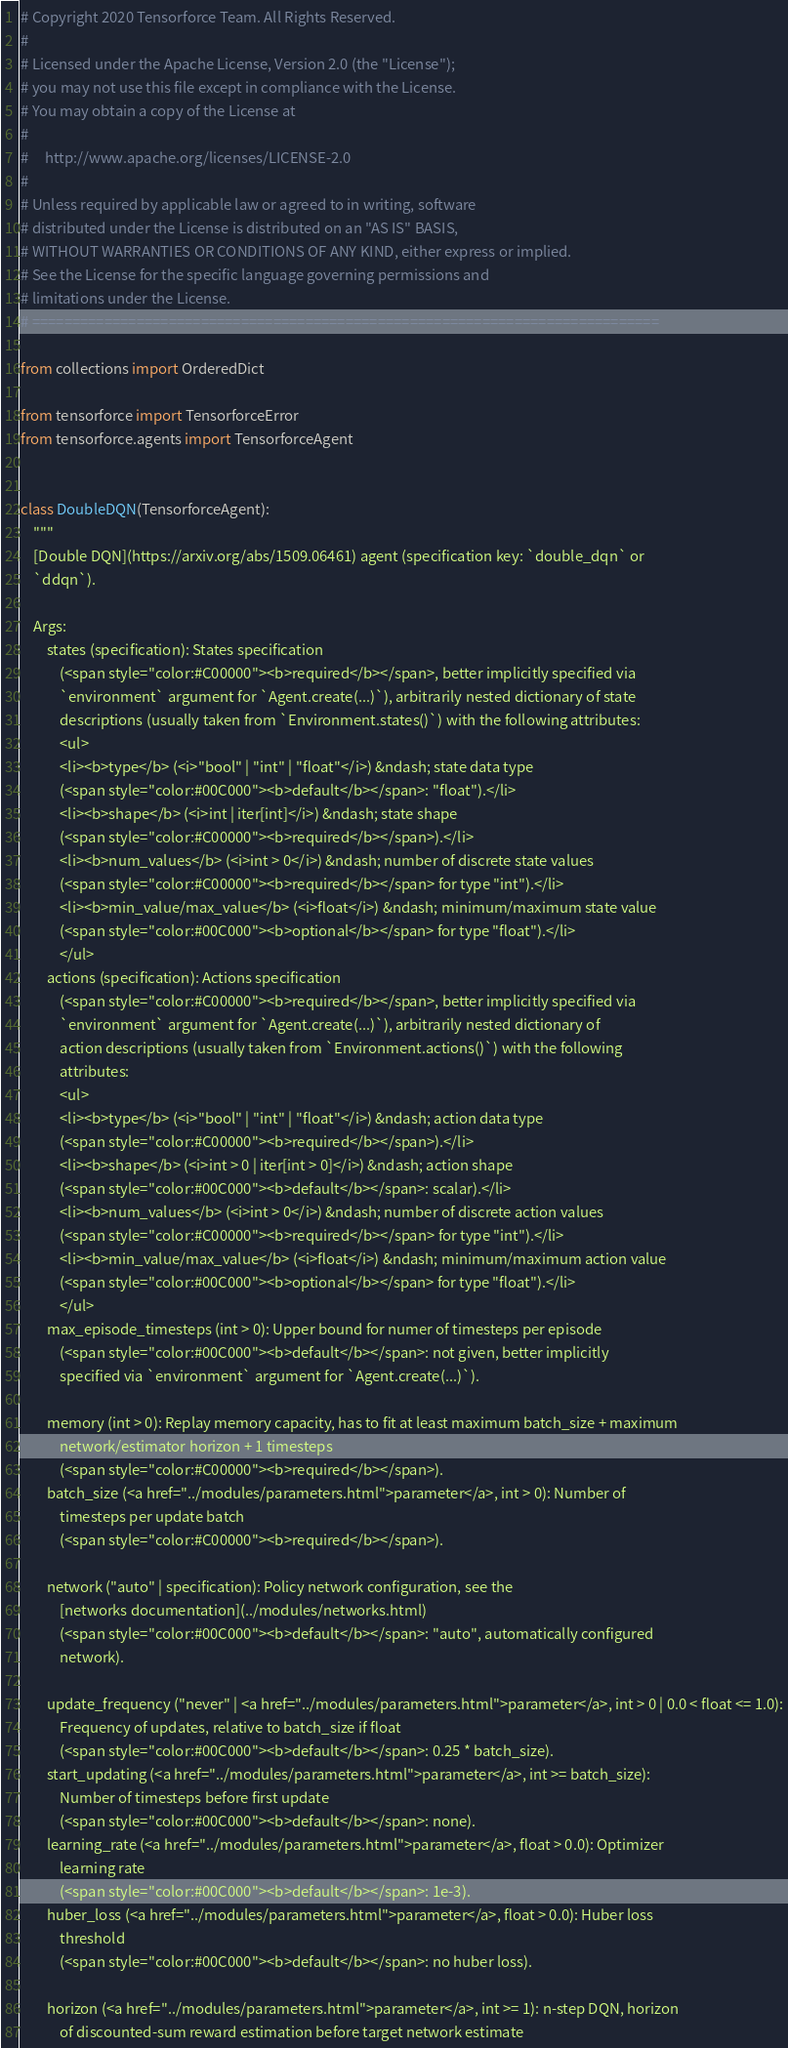<code> <loc_0><loc_0><loc_500><loc_500><_Python_># Copyright 2020 Tensorforce Team. All Rights Reserved.
#
# Licensed under the Apache License, Version 2.0 (the "License");
# you may not use this file except in compliance with the License.
# You may obtain a copy of the License at
#
#     http://www.apache.org/licenses/LICENSE-2.0
#
# Unless required by applicable law or agreed to in writing, software
# distributed under the License is distributed on an "AS IS" BASIS,
# WITHOUT WARRANTIES OR CONDITIONS OF ANY KIND, either express or implied.
# See the License for the specific language governing permissions and
# limitations under the License.
# ==============================================================================

from collections import OrderedDict

from tensorforce import TensorforceError
from tensorforce.agents import TensorforceAgent


class DoubleDQN(TensorforceAgent):
    """
    [Double DQN](https://arxiv.org/abs/1509.06461) agent (specification key: `double_dqn` or
    `ddqn`).

    Args:
        states (specification): States specification
            (<span style="color:#C00000"><b>required</b></span>, better implicitly specified via
            `environment` argument for `Agent.create(...)`), arbitrarily nested dictionary of state
            descriptions (usually taken from `Environment.states()`) with the following attributes:
            <ul>
            <li><b>type</b> (<i>"bool" | "int" | "float"</i>) &ndash; state data type
            (<span style="color:#00C000"><b>default</b></span>: "float").</li>
            <li><b>shape</b> (<i>int | iter[int]</i>) &ndash; state shape
            (<span style="color:#C00000"><b>required</b></span>).</li>
            <li><b>num_values</b> (<i>int > 0</i>) &ndash; number of discrete state values
            (<span style="color:#C00000"><b>required</b></span> for type "int").</li>
            <li><b>min_value/max_value</b> (<i>float</i>) &ndash; minimum/maximum state value
            (<span style="color:#00C000"><b>optional</b></span> for type "float").</li>
            </ul>
        actions (specification): Actions specification
            (<span style="color:#C00000"><b>required</b></span>, better implicitly specified via
            `environment` argument for `Agent.create(...)`), arbitrarily nested dictionary of
            action descriptions (usually taken from `Environment.actions()`) with the following
            attributes:
            <ul>
            <li><b>type</b> (<i>"bool" | "int" | "float"</i>) &ndash; action data type
            (<span style="color:#C00000"><b>required</b></span>).</li>
            <li><b>shape</b> (<i>int > 0 | iter[int > 0]</i>) &ndash; action shape
            (<span style="color:#00C000"><b>default</b></span>: scalar).</li>
            <li><b>num_values</b> (<i>int > 0</i>) &ndash; number of discrete action values
            (<span style="color:#C00000"><b>required</b></span> for type "int").</li>
            <li><b>min_value/max_value</b> (<i>float</i>) &ndash; minimum/maximum action value
            (<span style="color:#00C000"><b>optional</b></span> for type "float").</li>
            </ul>
        max_episode_timesteps (int > 0): Upper bound for numer of timesteps per episode
            (<span style="color:#00C000"><b>default</b></span>: not given, better implicitly
            specified via `environment` argument for `Agent.create(...)`).

        memory (int > 0): Replay memory capacity, has to fit at least maximum batch_size + maximum
            network/estimator horizon + 1 timesteps
            (<span style="color:#C00000"><b>required</b></span>).
        batch_size (<a href="../modules/parameters.html">parameter</a>, int > 0): Number of
            timesteps per update batch
            (<span style="color:#C00000"><b>required</b></span>).

        network ("auto" | specification): Policy network configuration, see the
            [networks documentation](../modules/networks.html)
            (<span style="color:#00C000"><b>default</b></span>: "auto", automatically configured
            network).

        update_frequency ("never" | <a href="../modules/parameters.html">parameter</a>, int > 0 | 0.0 < float <= 1.0):
            Frequency of updates, relative to batch_size if float
            (<span style="color:#00C000"><b>default</b></span>: 0.25 * batch_size).
        start_updating (<a href="../modules/parameters.html">parameter</a>, int >= batch_size):
            Number of timesteps before first update
            (<span style="color:#00C000"><b>default</b></span>: none).
        learning_rate (<a href="../modules/parameters.html">parameter</a>, float > 0.0): Optimizer
            learning rate
            (<span style="color:#00C000"><b>default</b></span>: 1e-3).
        huber_loss (<a href="../modules/parameters.html">parameter</a>, float > 0.0): Huber loss
            threshold
            (<span style="color:#00C000"><b>default</b></span>: no huber loss).

        horizon (<a href="../modules/parameters.html">parameter</a>, int >= 1): n-step DQN, horizon
            of discounted-sum reward estimation before target network estimate</code> 